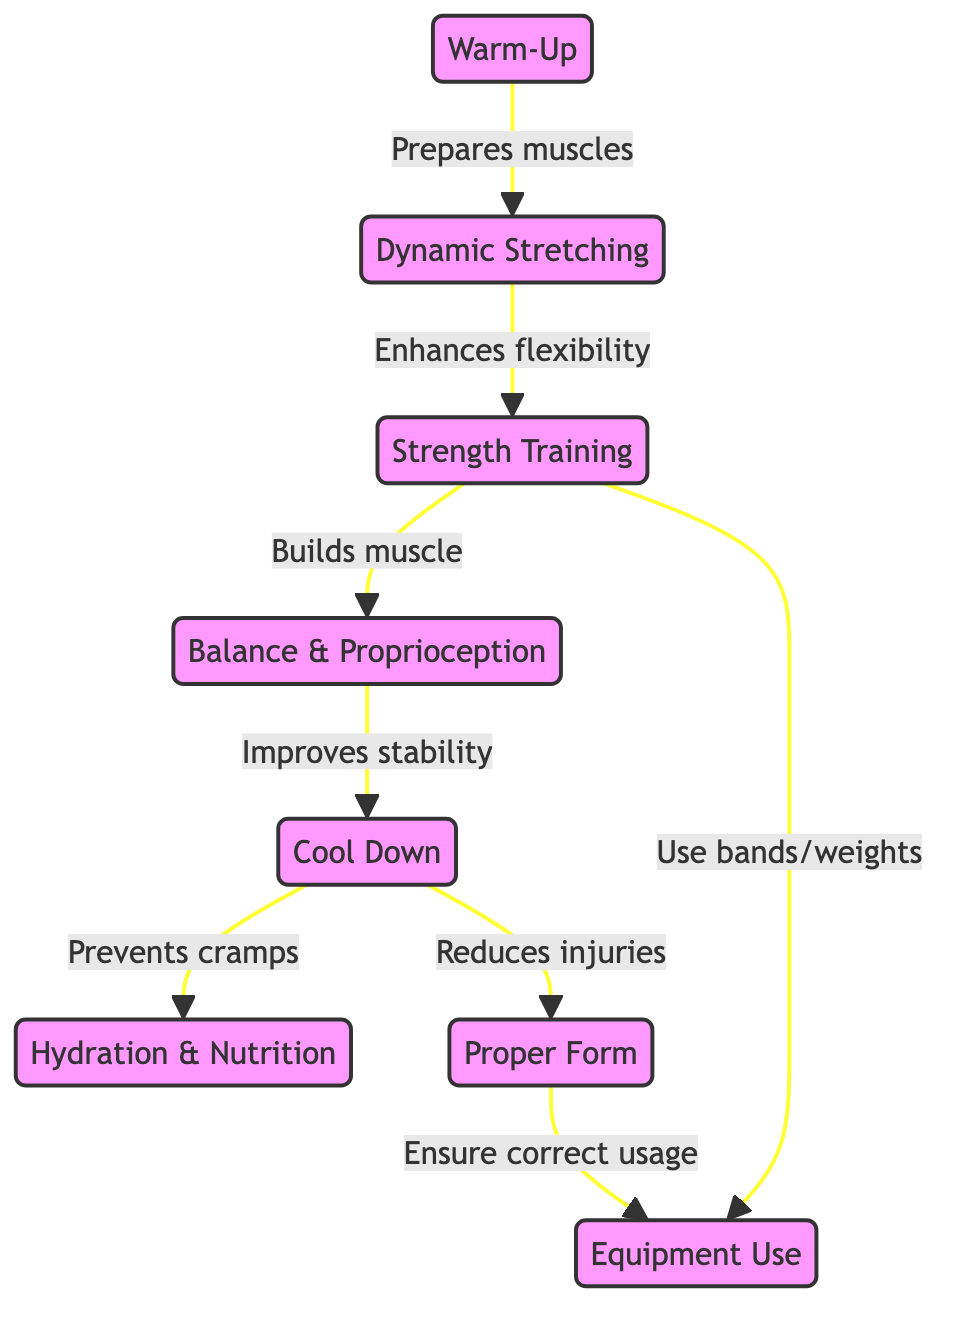What is the first step in the injury prevention program? The diagram shows "Warm-Up" as the first node, which indicates it is the first step in the injury prevention program.
Answer: Warm-Up How many nodes are present in the diagram? By counting each distinct step or element represented in the diagram, there are a total of 8 nodes: Warm-Up, Dynamic Stretching, Strength Training, Balance & Proprioception, Cool Down, Hydration & Nutrition, Equipment Use, and Proper Form.
Answer: 8 What does "Strength Training" lead to in the diagram? According to the connections in the diagram, "Strength Training" leads to both "Balance & Proprioception" and "Equipment Use," indicating its role in improving stability and proper equipment usage.
Answer: Balance & Proprioception, Equipment Use Which activity prevents cramps according to the flowchart? The diagram indicates that "Cool Down" prevents cramps, highlighting its importance as a cooling activity following exercise.
Answer: Cool Down What does "Dynamic Stretching" enhance? The diagram explicitly states that "Dynamic Stretching" enhances flexibility, establishing a direct link to its function in the program.
Answer: Flexibility What are the two outcomes of "Cool Down" in the program? The connections from "Cool Down" show it has two outcomes: it prevents cramps and reduces injuries. This indicates its dual purpose in the injury prevention program.
Answer: Prevents cramps, Reduces injuries What should be ensured for "Proper Form"? The diagram highlights that "Proper Form" aims to ensure correct usage of equipment, showing its critical role in the safety and effectiveness of exercise routines.
Answer: Ensure correct usage What follows "Balance & Proprioception" in the diagram? The flowchart shows that "Balance & Proprioception" leads to "Cool Down," which signifies its placement in the injury prevention sequence.
Answer: Cool Down Which activity comes after "Warm-Up"? The diagram indicates that following the "Warm-Up," the next activity is "Dynamic Stretching," showing the progression of the injury prevention program.
Answer: Dynamic Stretching 